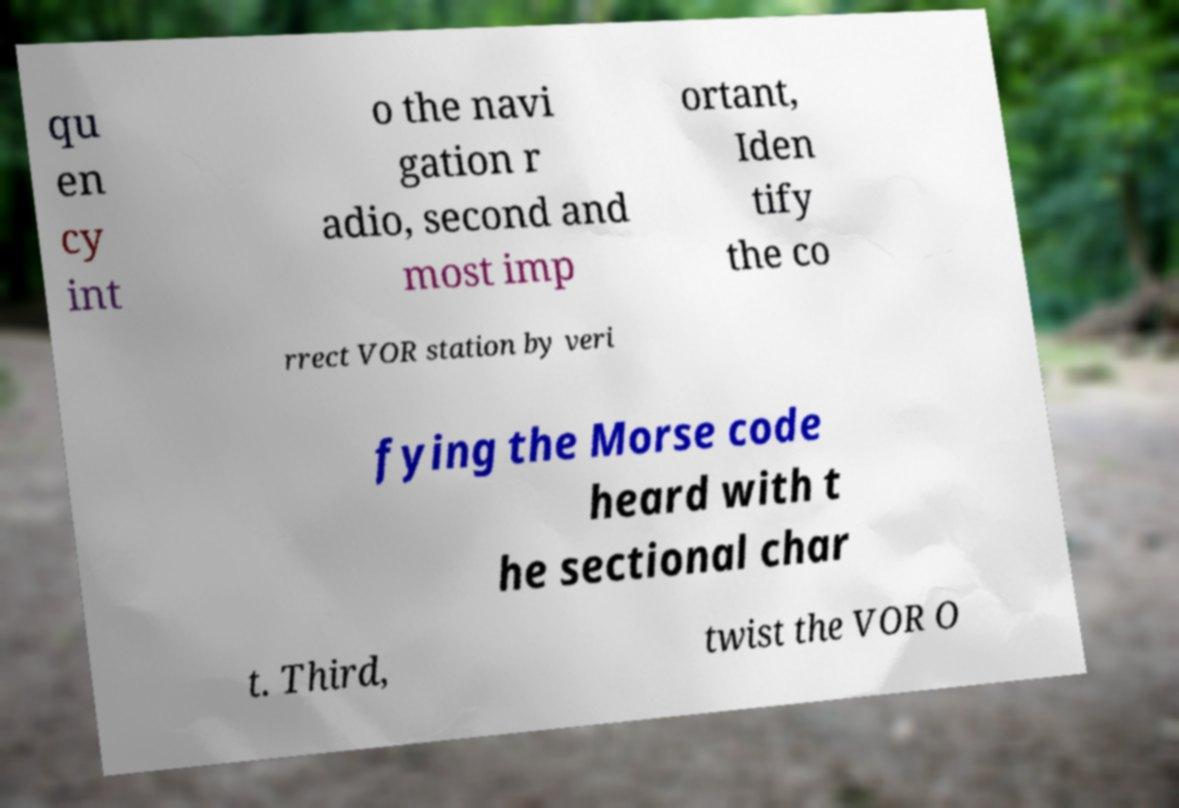Please read and relay the text visible in this image. What does it say? qu en cy int o the navi gation r adio, second and most imp ortant, Iden tify the co rrect VOR station by veri fying the Morse code heard with t he sectional char t. Third, twist the VOR O 